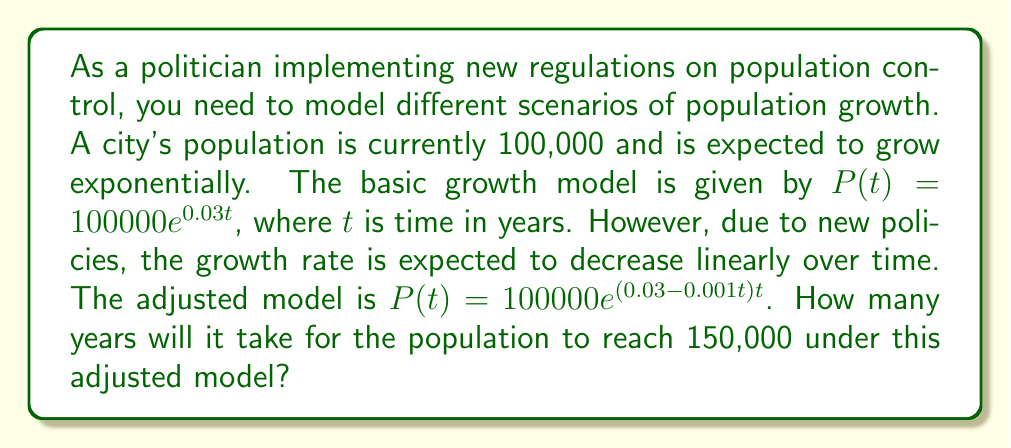Can you answer this question? To solve this problem, we need to follow these steps:

1) We start with the adjusted population model:
   $P(t) = 100000e^{(0.03 - 0.001t)t}$

2) We want to find $t$ when $P(t) = 150000$. So, we set up the equation:
   $150000 = 100000e^{(0.03 - 0.001t)t}$

3) Divide both sides by 100000:
   $1.5 = e^{(0.03 - 0.001t)t}$

4) Take the natural logarithm of both sides:
   $\ln(1.5) = (0.03 - 0.001t)t$

5) Expand the right side:
   $\ln(1.5) = 0.03t - 0.001t^2$

6) Rearrange to standard quadratic form:
   $0.001t^2 - 0.03t + \ln(1.5) = 0$

7) This is a quadratic equation in the form $at^2 + bt + c = 0$, where:
   $a = 0.001$
   $b = -0.03$
   $c = \ln(1.5) \approx 0.4055$

8) We can solve this using the quadratic formula: $t = \frac{-b \pm \sqrt{b^2 - 4ac}}{2a}$

9) Plugging in the values:
   $t = \frac{0.03 \pm \sqrt{(-0.03)^2 - 4(0.001)(0.4055)}}{2(0.001)}$

10) Simplify:
    $t = \frac{0.03 \pm \sqrt{0.0009 - 0.001622}}{0.002}$
    $t = \frac{0.03 \pm \sqrt{-0.000722}}{0.002}$

11) The negative value under the square root indicates that there are no real solutions. This means the population never reaches exactly 150,000 under this model.

12) However, we can find when the population is closest to 150,000 by finding the maximum of the function. To do this, we take the derivative of $P(t)$ and set it to zero:

    $P'(t) = 100000e^{(0.03 - 0.001t)t}(0.03 - 0.001t - 0.001t) = 0$

13) Solving this equation:
    $0.03 - 0.002t = 0$
    $t = 15$

14) This means the population reaches its maximum at $t = 15$ years. We can check the population at this time:

    $P(15) = 100000e^{(0.03 - 0.001(15))(15)} \approx 149,182$

Therefore, the population gets closest to 150,000 after approximately 15 years, reaching about 149,182.
Answer: The population never exactly reaches 150,000 under this model. It gets closest to 150,000 after approximately 15 years, reaching about 149,182. 